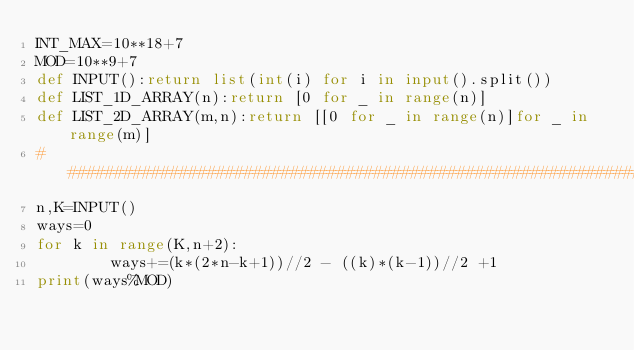<code> <loc_0><loc_0><loc_500><loc_500><_Python_>INT_MAX=10**18+7
MOD=10**9+7
def INPUT():return list(int(i) for i in input().split())
def LIST_1D_ARRAY(n):return [0 for _ in range(n)]
def LIST_2D_ARRAY(m,n):return [[0 for _ in range(n)]for _ in range(m)]
#################################################################################
n,K=INPUT()
ways=0
for k in range(K,n+2):
        ways+=(k*(2*n-k+1))//2 - ((k)*(k-1))//2 +1
print(ways%MOD)
</code> 